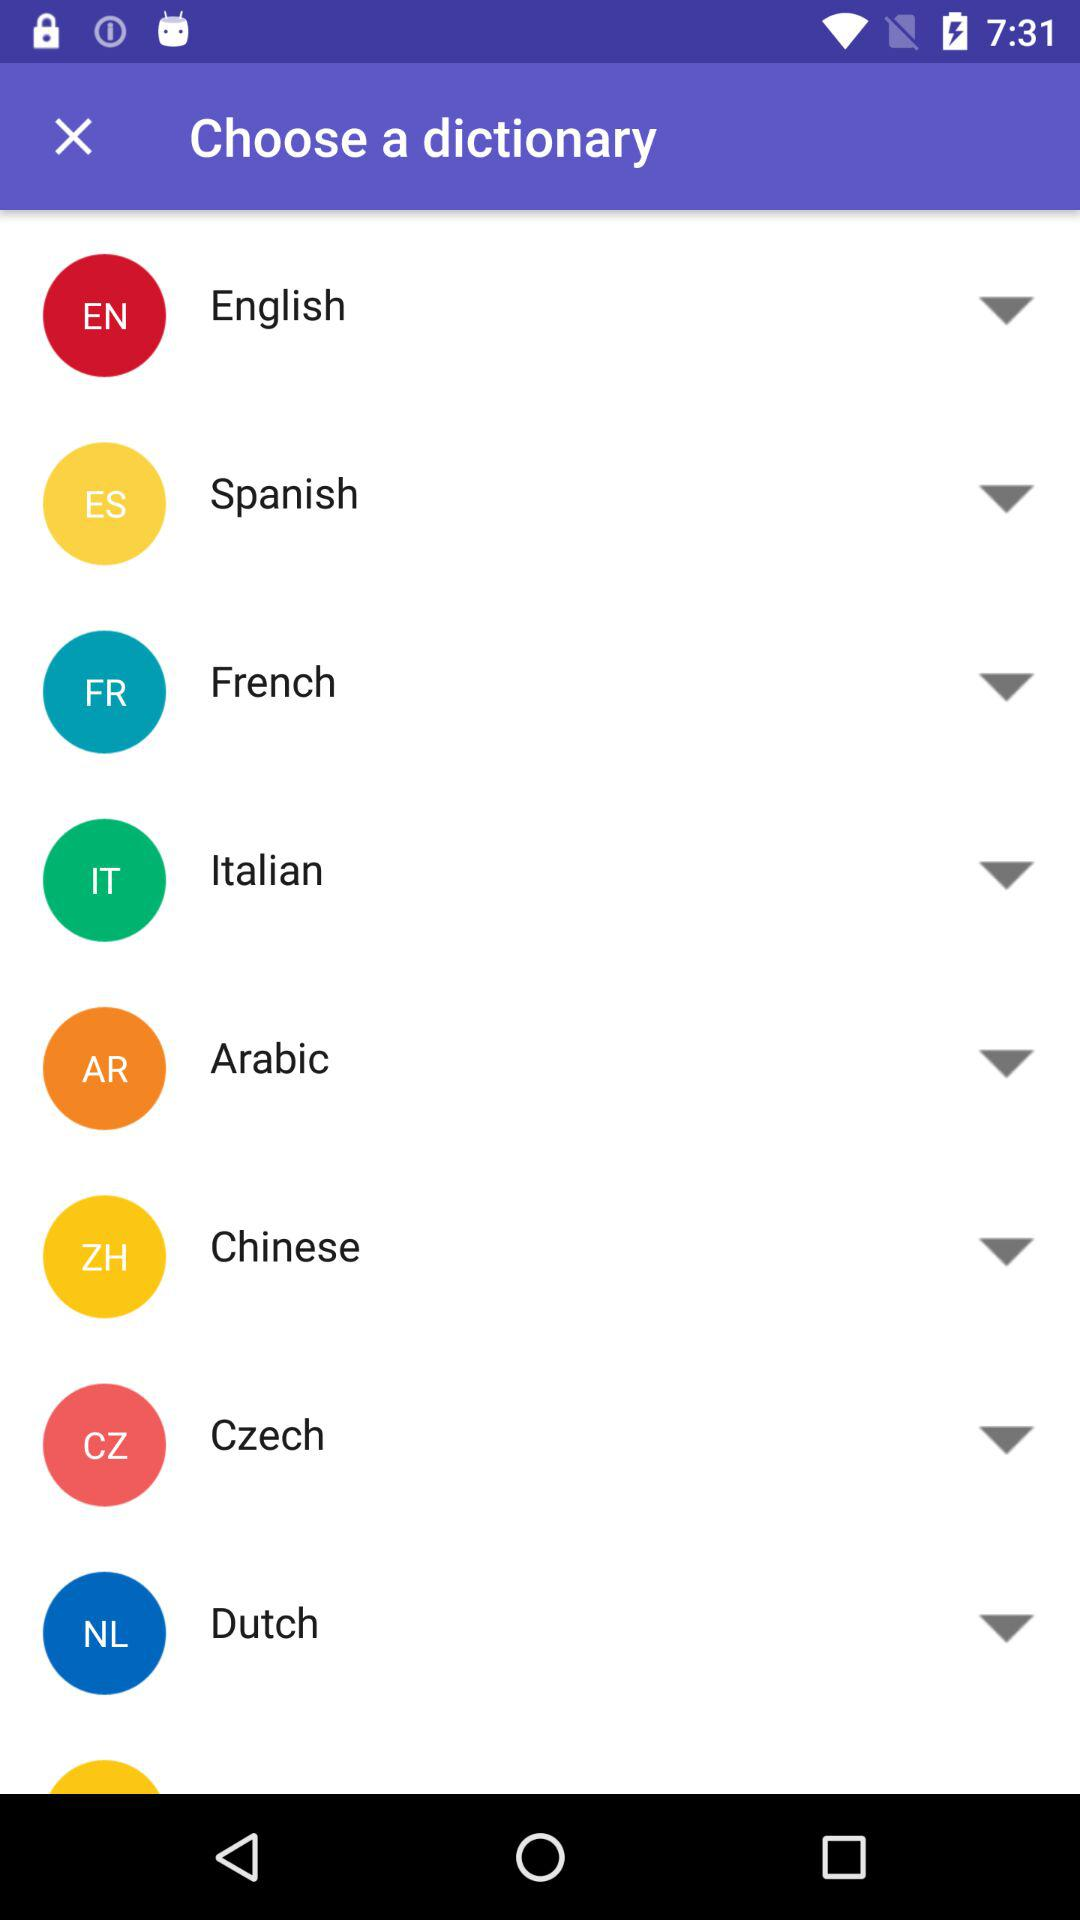How many languages are available to choose from?
Answer the question using a single word or phrase. 8 